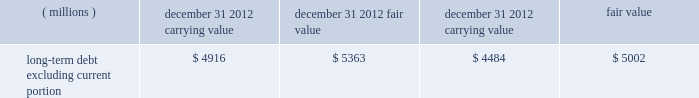Fair value of financial instruments : the company 2019s financial instruments include cash and cash equivalents , marketable securities , accounts receivable , certain investments , accounts payable , borrowings , and derivative contracts .
The fair values of cash and cash equivalents , accounts receivable , accounts payable , and short-term borrowings and current portion of long-term debt approximated carrying values because of the short-term nature of these instruments .
Available-for-sale marketable securities and investments , in addition to certain derivative instruments , are recorded at fair values as indicated in the preceding disclosures .
For its long-term debt the company utilized third-party quotes to estimate fair values ( classified as level 2 ) .
Information with respect to the carrying amounts and estimated fair values of these financial instruments follow: .
The fair values reflected above consider the terms of the related debt absent the impacts of derivative/hedging activity .
The carrying amount of long-term debt referenced above is impacted by certain fixed-to-floating interest rate swaps that are designated as fair value hedges and by the designation of fixed rate eurobond securities issued by the company as hedging instruments of the company 2019s net investment in its european subsidiaries .
3m 2019s fixed-rate bonds were trading at a premium at december 31 , 2012 and 2011 due to the low interest rates and tightening of 3m 2019s credit spreads. .
In december 2012 what was the percentage difference in the carrying values of the long-term debt excluding current portion? 
Rationale: december 2012 the percentage difference in the carrying values of the long-term debt excluding current portion was 9.63%
Computations: ((4916 - 4484) / 4484)
Answer: 0.09634. 